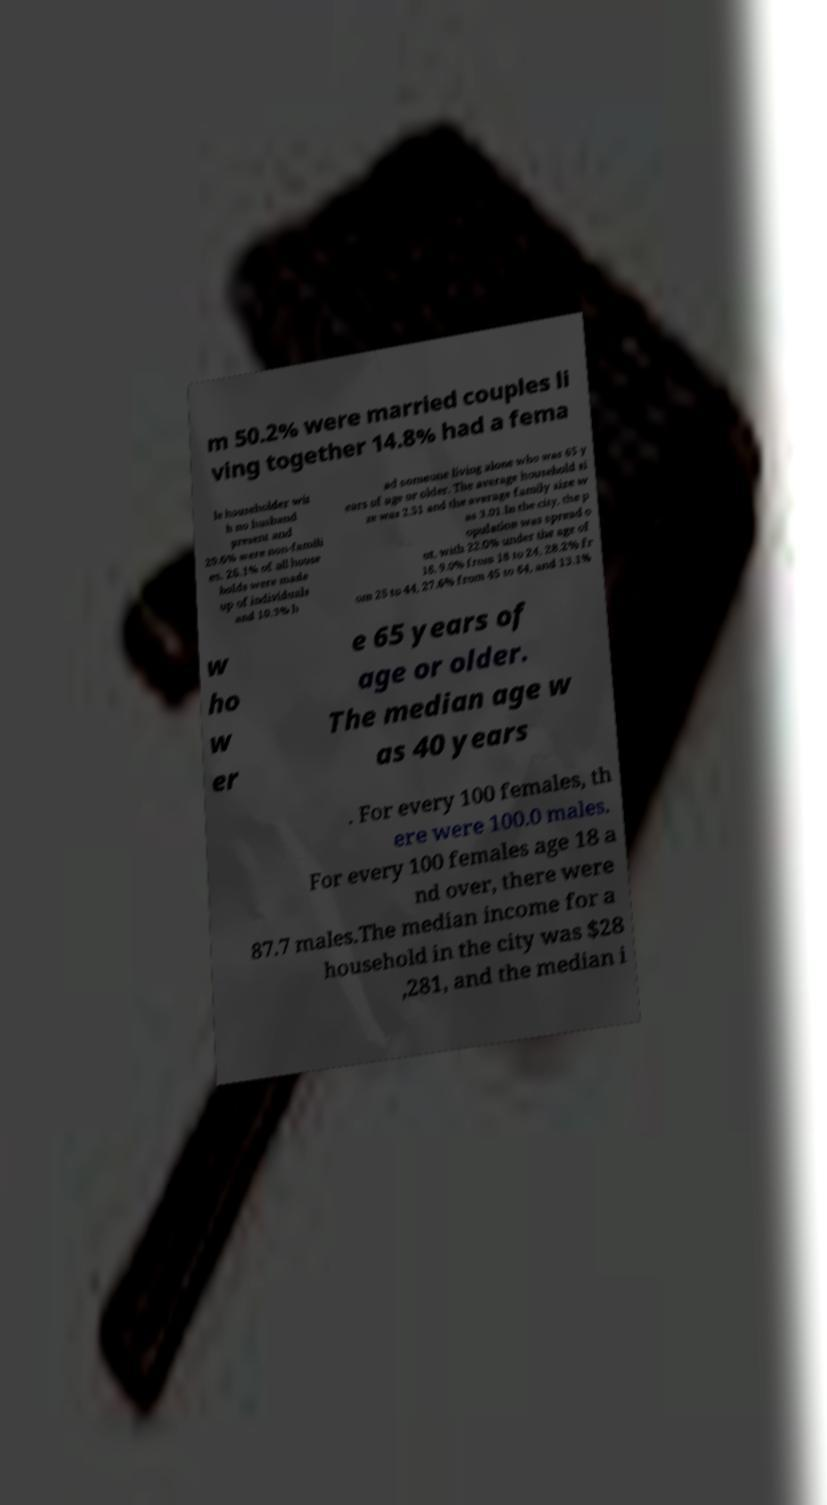I need the written content from this picture converted into text. Can you do that? m 50.2% were married couples li ving together 14.8% had a fema le householder wit h no husband present and 29.6% were non-famili es. 26.1% of all house holds were made up of individuals and 10.3% h ad someone living alone who was 65 y ears of age or older. The average household si ze was 2.51 and the average family size w as 3.01.In the city, the p opulation was spread o ut, with 22.0% under the age of 18, 9.0% from 18 to 24, 28.2% fr om 25 to 44, 27.6% from 45 to 64, and 13.1% w ho w er e 65 years of age or older. The median age w as 40 years . For every 100 females, th ere were 100.0 males. For every 100 females age 18 a nd over, there were 87.7 males.The median income for a household in the city was $28 ,281, and the median i 